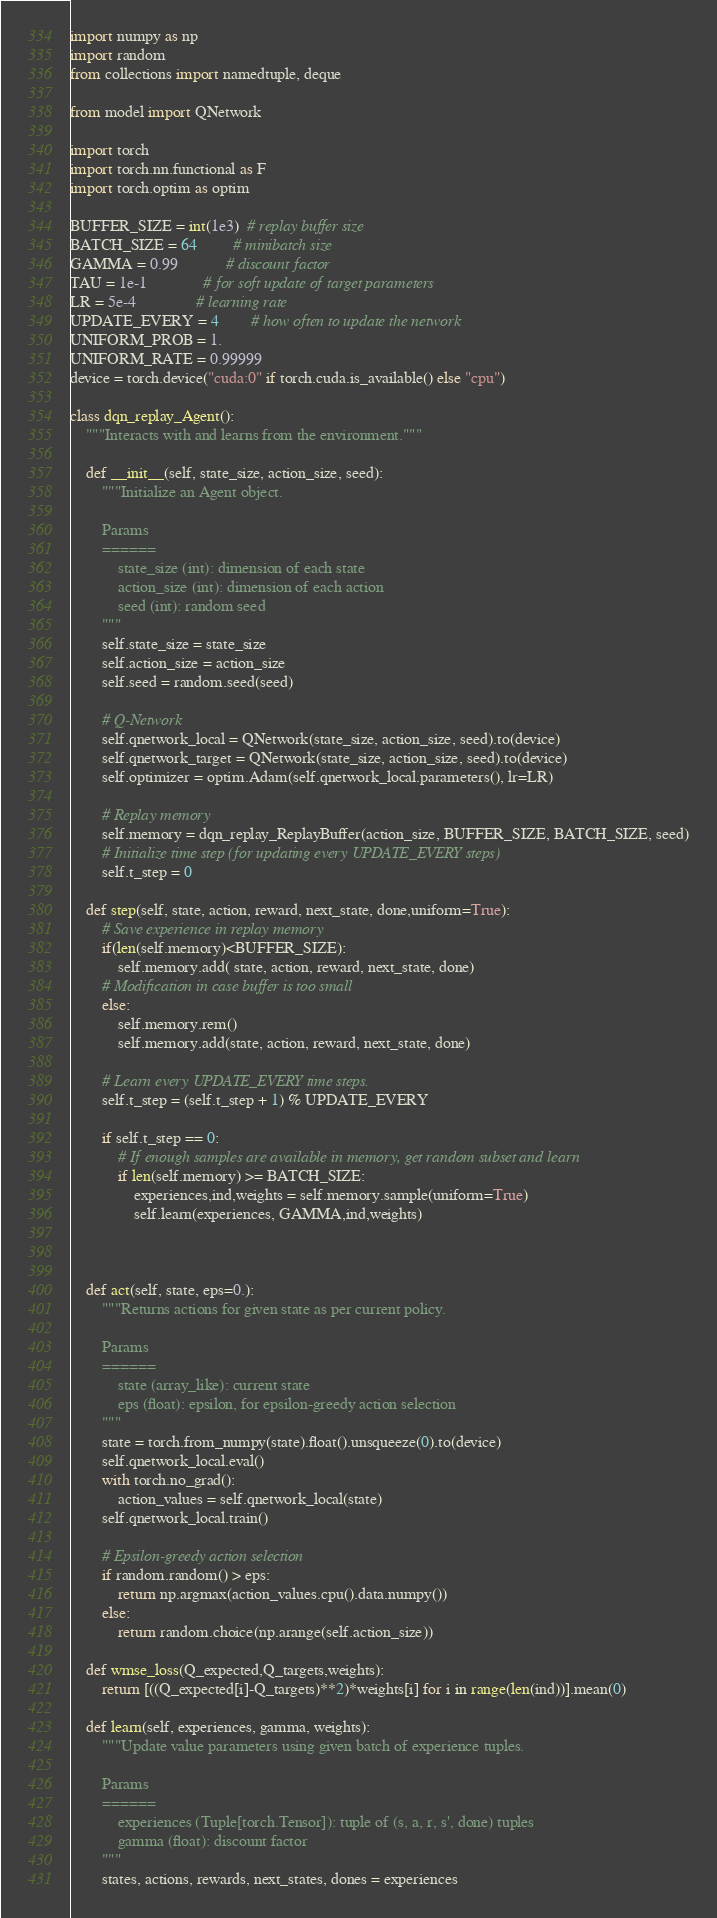<code> <loc_0><loc_0><loc_500><loc_500><_Python_>import numpy as np
import random
from collections import namedtuple, deque

from model import QNetwork

import torch
import torch.nn.functional as F
import torch.optim as optim

BUFFER_SIZE = int(1e3)  # replay buffer size
BATCH_SIZE = 64         # minibatch size
GAMMA = 0.99            # discount factor
TAU = 1e-1              # for soft update of target parameters
LR = 5e-4               # learning rate 
UPDATE_EVERY = 4        # how often to update the network
UNIFORM_PROB = 1.
UNIFORM_RATE = 0.99999
device = torch.device("cuda:0" if torch.cuda.is_available() else "cpu")

class dqn_replay_Agent():
    """Interacts with and learns from the environment."""

    def __init__(self, state_size, action_size, seed):
        """Initialize an Agent object.
        
        Params
        ======
            state_size (int): dimension of each state
            action_size (int): dimension of each action
            seed (int): random seed
        """
        self.state_size = state_size
        self.action_size = action_size
        self.seed = random.seed(seed)

        # Q-Network
        self.qnetwork_local = QNetwork(state_size, action_size, seed).to(device)
        self.qnetwork_target = QNetwork(state_size, action_size, seed).to(device)
        self.optimizer = optim.Adam(self.qnetwork_local.parameters(), lr=LR)

        # Replay memory
        self.memory = dqn_replay_ReplayBuffer(action_size, BUFFER_SIZE, BATCH_SIZE, seed)
        # Initialize time step (for updating every UPDATE_EVERY steps)
        self.t_step = 0
    
    def step(self, state, action, reward, next_state, done,uniform=True):
        # Save experience in replay memory
        if(len(self.memory)<BUFFER_SIZE):
            self.memory.add( state, action, reward, next_state, done)
        # Modification in case buffer is too small
        else:
            self.memory.rem()
            self.memory.add(state, action, reward, next_state, done)

        # Learn every UPDATE_EVERY time steps.
        self.t_step = (self.t_step + 1) % UPDATE_EVERY

        if self.t_step == 0:
            # If enough samples are available in memory, get random subset and learn
            if len(self.memory) >= BATCH_SIZE:
                experiences,ind,weights = self.memory.sample(uniform=True)
                self.learn(experiences, GAMMA,ind,weights)

                
                
    def act(self, state, eps=0.):
        """Returns actions for given state as per current policy.
        
        Params
        ======
            state (array_like): current state
            eps (float): epsilon, for epsilon-greedy action selection
        """
        state = torch.from_numpy(state).float().unsqueeze(0).to(device)
        self.qnetwork_local.eval()
        with torch.no_grad():
            action_values = self.qnetwork_local(state)
        self.qnetwork_local.train()

        # Epsilon-greedy action selection
        if random.random() > eps:
            return np.argmax(action_values.cpu().data.numpy())
        else:
            return random.choice(np.arange(self.action_size))
        
    def wmse_loss(Q_expected,Q_targets,weights):
        return [((Q_expected[i]-Q_targets)**2)*weights[i] for i in range(len(ind))].mean(0)
  
    def learn(self, experiences, gamma, weights):
        """Update value parameters using given batch of experience tuples.

        Params
        ======
            experiences (Tuple[torch.Tensor]): tuple of (s, a, r, s', done) tuples 
            gamma (float): discount factor
        """
        states, actions, rewards, next_states, dones = experiences
</code> 